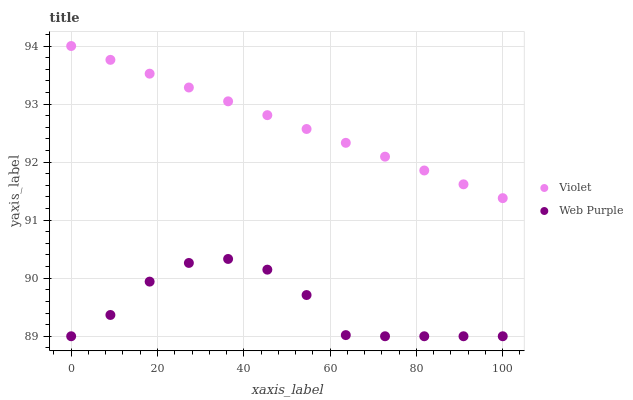Does Web Purple have the minimum area under the curve?
Answer yes or no. Yes. Does Violet have the maximum area under the curve?
Answer yes or no. Yes. Does Violet have the minimum area under the curve?
Answer yes or no. No. Is Violet the smoothest?
Answer yes or no. Yes. Is Web Purple the roughest?
Answer yes or no. Yes. Is Violet the roughest?
Answer yes or no. No. Does Web Purple have the lowest value?
Answer yes or no. Yes. Does Violet have the lowest value?
Answer yes or no. No. Does Violet have the highest value?
Answer yes or no. Yes. Is Web Purple less than Violet?
Answer yes or no. Yes. Is Violet greater than Web Purple?
Answer yes or no. Yes. Does Web Purple intersect Violet?
Answer yes or no. No. 